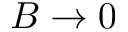Convert formula to latex. <formula><loc_0><loc_0><loc_500><loc_500>B \rightarrow 0</formula> 